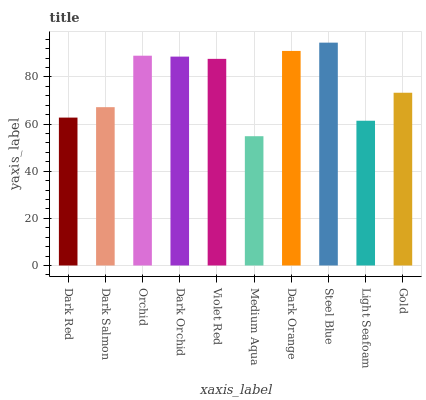Is Medium Aqua the minimum?
Answer yes or no. Yes. Is Steel Blue the maximum?
Answer yes or no. Yes. Is Dark Salmon the minimum?
Answer yes or no. No. Is Dark Salmon the maximum?
Answer yes or no. No. Is Dark Salmon greater than Dark Red?
Answer yes or no. Yes. Is Dark Red less than Dark Salmon?
Answer yes or no. Yes. Is Dark Red greater than Dark Salmon?
Answer yes or no. No. Is Dark Salmon less than Dark Red?
Answer yes or no. No. Is Violet Red the high median?
Answer yes or no. Yes. Is Gold the low median?
Answer yes or no. Yes. Is Dark Orchid the high median?
Answer yes or no. No. Is Dark Orange the low median?
Answer yes or no. No. 